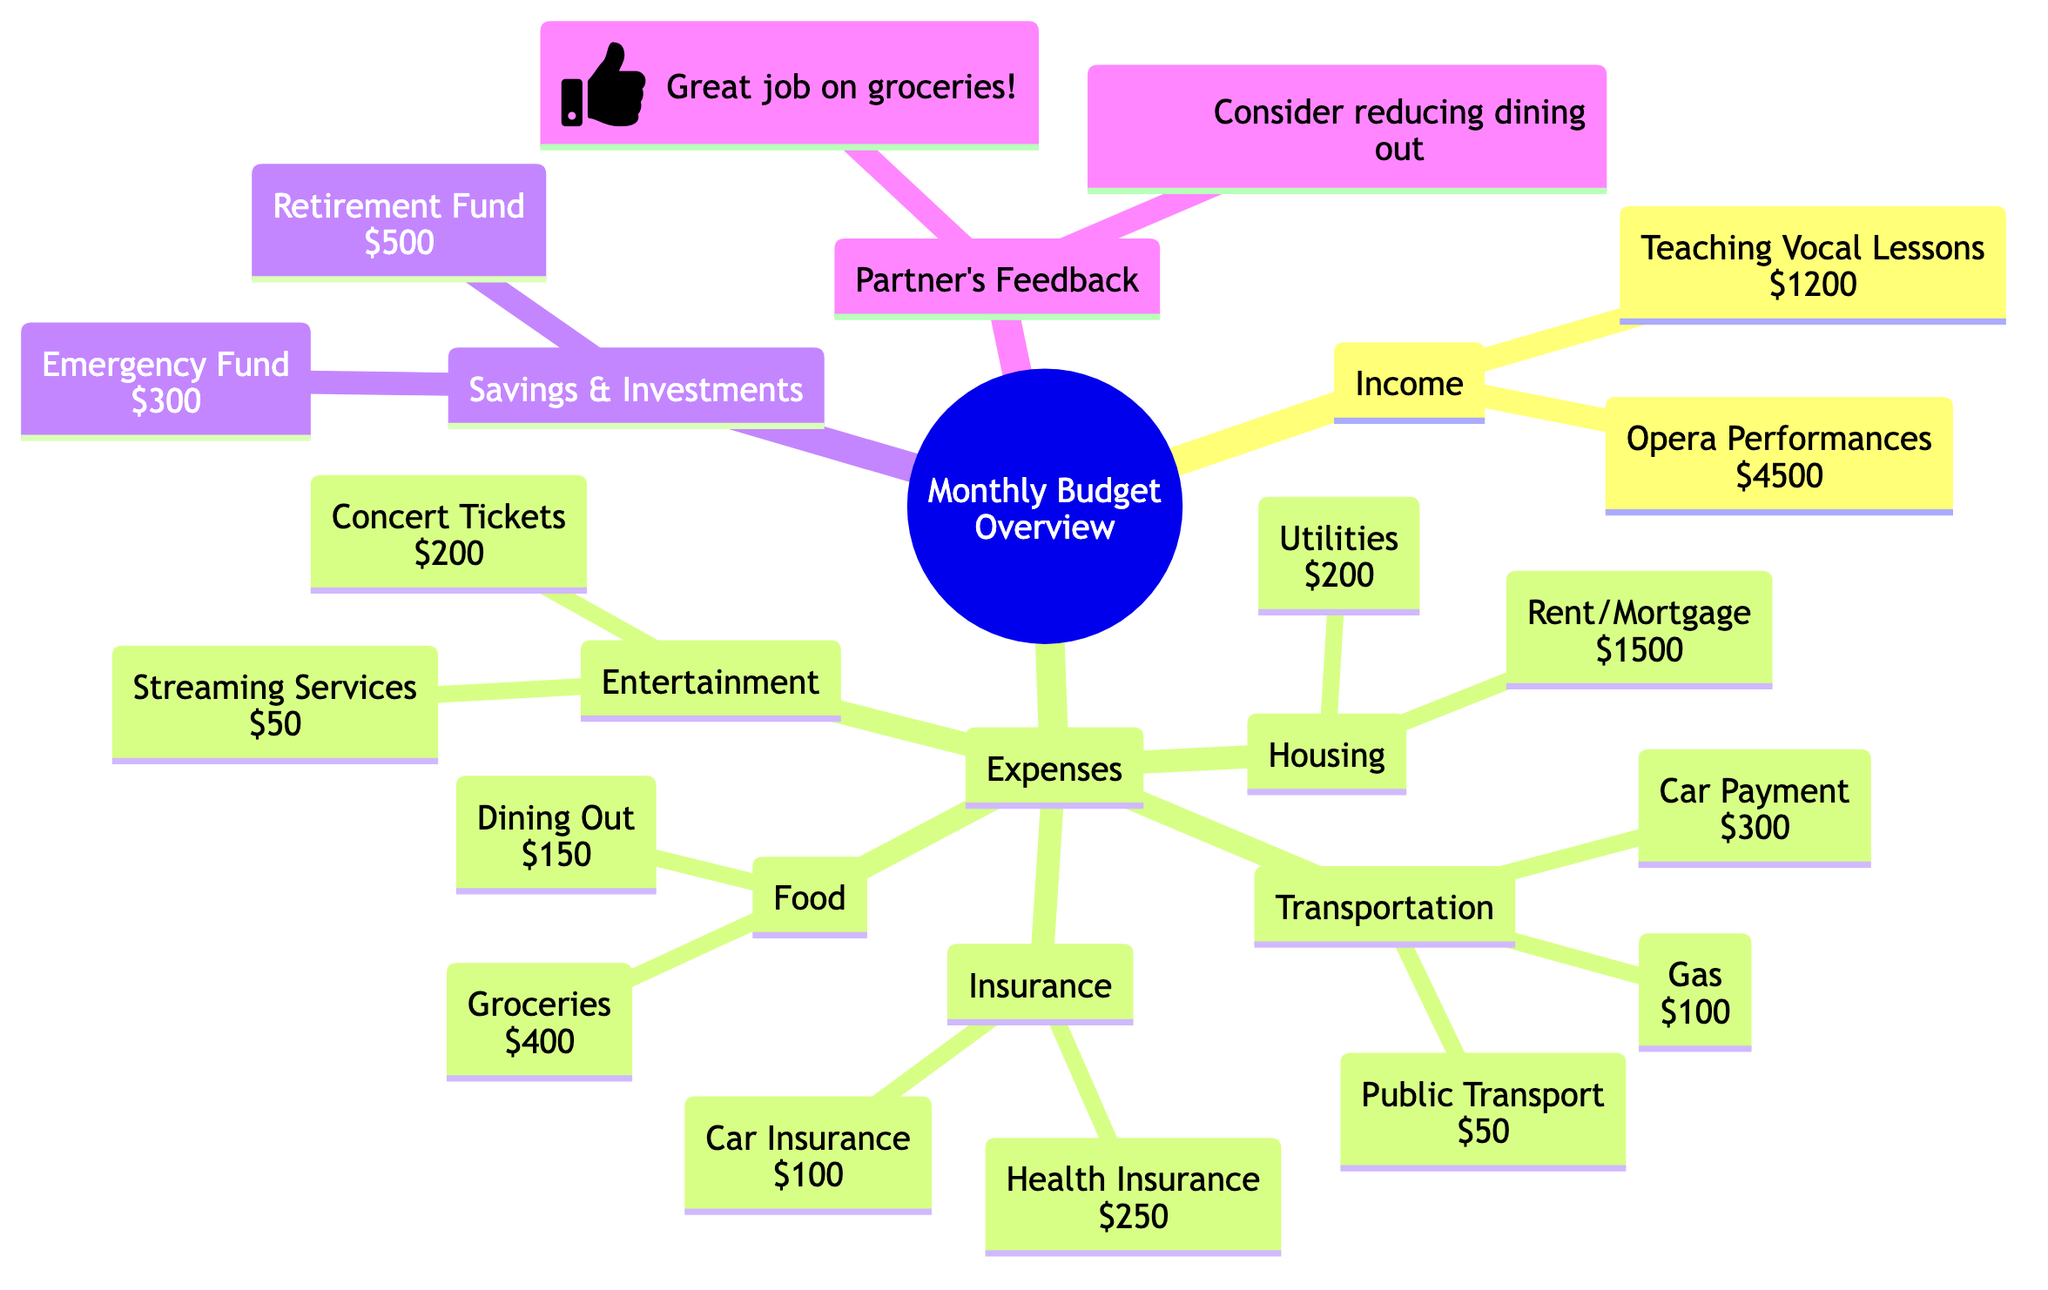What is the total income from opera performances? The diagram specifies that income from opera performances is listed as $4500, so this is the total income generated from this category.
Answer: $4500 How much is allocated for groceries? The expense category for food shows that groceries are allocated $400, making this the figure for grocery expenses.
Answer: $400 What is the total amount spent on insurance? The insurance category consists of Health Insurance at $250 and Car Insurance at $100. Adding these amounts together gives $250 + $100 = $350.
Answer: $350 What is the total of the emergency and retirement funds? The savings and investments portion indicates an Emergency Fund of $300 and a Retirement Fund of $500. Combining these amounts, $300 + $500 results in $800 as the total for both funds.
Answer: $800 How many expense categories are shown in the diagram? The diagram lists five main categories under Expenses: Housing, Transportation, Food, Insurance, and Entertainment. Therefore, there are a total of five expense categories.
Answer: 5 What is the difference between the total income and total expenses? First, we calculate total income: $4500 (performances) + $1200 (teaching) = $5700. Next, we add the expenses: Rent/Mortgage $1500 + Utilities $200 + Car Payment $300 + Gas $100 + Public Transport $50 + Groceries $400 + Dining Out $150 + Health Insurance $250 + Car Insurance $100 + Concert Tickets $200 + Streaming Services $50 = $3050. Now we subtract the total expenses from total income: $5700 - $3050 = $2650.
Answer: $2650 What is the feedback provided for dining out? The diagram creatively includes the partner's feedback, which highlights the suggestion to consider reducing dining out. This feedback directly implies a recommendation in this expense category.
Answer: Consider reducing dining out How many income sources are there? The diagram indicates two sources of income: Opera Performances and Teaching Vocal Lessons. Thus, there are two distinct income sources.
Answer: 2 What did the partner think about the groceries? In the partner's feedback section, it is positively noted as "Great job on groceries!" This explicitly indicates approval regarding grocery expenses.
Answer: Great job on groceries! 